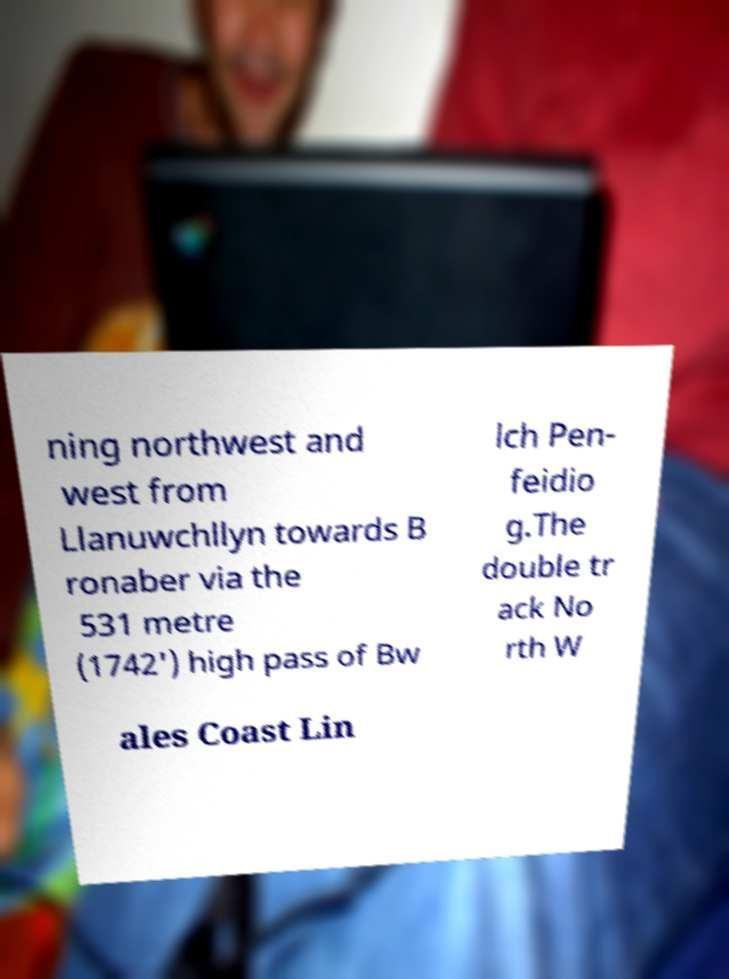I need the written content from this picture converted into text. Can you do that? ning northwest and west from Llanuwchllyn towards B ronaber via the 531 metre (1742') high pass of Bw lch Pen- feidio g.The double tr ack No rth W ales Coast Lin 